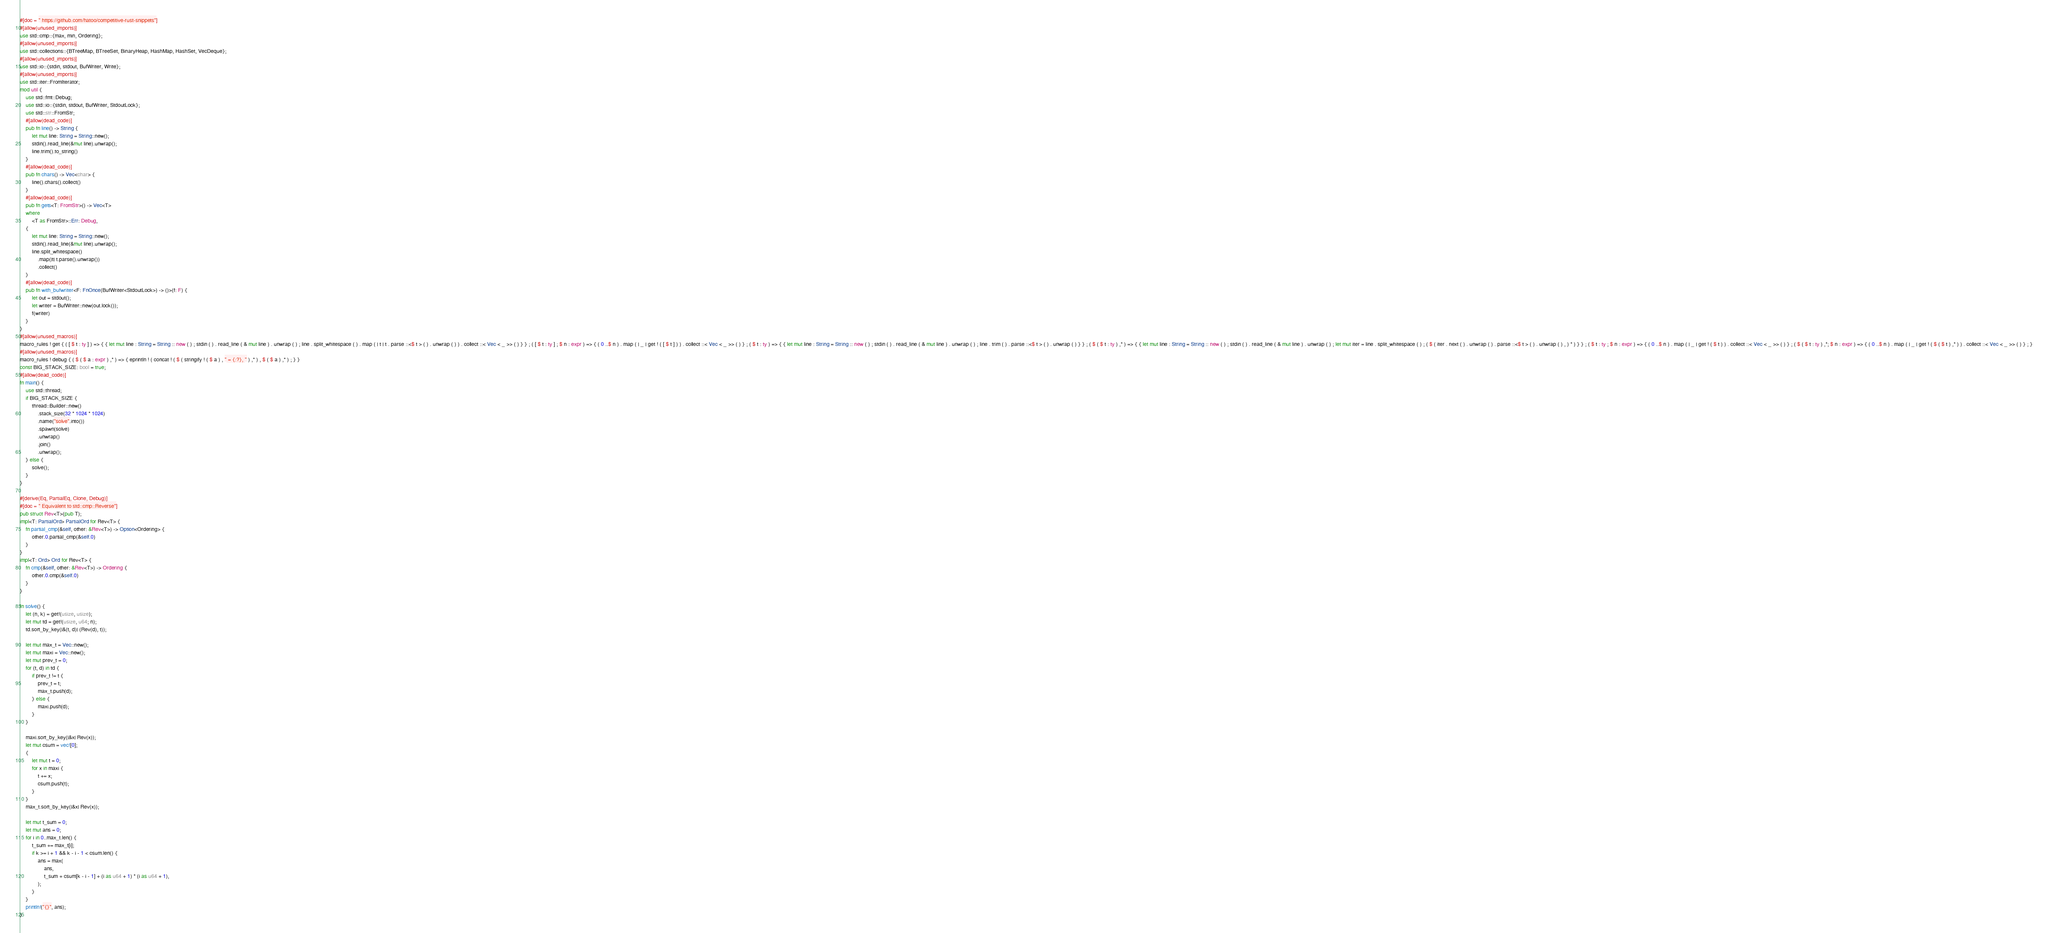<code> <loc_0><loc_0><loc_500><loc_500><_Rust_>#[doc = " https://github.com/hatoo/competitive-rust-snippets"]
#[allow(unused_imports)]
use std::cmp::{max, min, Ordering};
#[allow(unused_imports)]
use std::collections::{BTreeMap, BTreeSet, BinaryHeap, HashMap, HashSet, VecDeque};
#[allow(unused_imports)]
use std::io::{stdin, stdout, BufWriter, Write};
#[allow(unused_imports)]
use std::iter::FromIterator;
mod util {
    use std::fmt::Debug;
    use std::io::{stdin, stdout, BufWriter, StdoutLock};
    use std::str::FromStr;
    #[allow(dead_code)]
    pub fn line() -> String {
        let mut line: String = String::new();
        stdin().read_line(&mut line).unwrap();
        line.trim().to_string()
    }
    #[allow(dead_code)]
    pub fn chars() -> Vec<char> {
        line().chars().collect()
    }
    #[allow(dead_code)]
    pub fn gets<T: FromStr>() -> Vec<T>
    where
        <T as FromStr>::Err: Debug,
    {
        let mut line: String = String::new();
        stdin().read_line(&mut line).unwrap();
        line.split_whitespace()
            .map(|t| t.parse().unwrap())
            .collect()
    }
    #[allow(dead_code)]
    pub fn with_bufwriter<F: FnOnce(BufWriter<StdoutLock>) -> ()>(f: F) {
        let out = stdout();
        let writer = BufWriter::new(out.lock());
        f(writer)
    }
}
#[allow(unused_macros)]
macro_rules ! get { ( [ $ t : ty ] ) => { { let mut line : String = String :: new ( ) ; stdin ( ) . read_line ( & mut line ) . unwrap ( ) ; line . split_whitespace ( ) . map ( | t | t . parse ::<$ t > ( ) . unwrap ( ) ) . collect ::< Vec < _ >> ( ) } } ; ( [ $ t : ty ] ; $ n : expr ) => { ( 0 ..$ n ) . map ( | _ | get ! ( [ $ t ] ) ) . collect ::< Vec < _ >> ( ) } ; ( $ t : ty ) => { { let mut line : String = String :: new ( ) ; stdin ( ) . read_line ( & mut line ) . unwrap ( ) ; line . trim ( ) . parse ::<$ t > ( ) . unwrap ( ) } } ; ( $ ( $ t : ty ) ,* ) => { { let mut line : String = String :: new ( ) ; stdin ( ) . read_line ( & mut line ) . unwrap ( ) ; let mut iter = line . split_whitespace ( ) ; ( $ ( iter . next ( ) . unwrap ( ) . parse ::<$ t > ( ) . unwrap ( ) , ) * ) } } ; ( $ t : ty ; $ n : expr ) => { ( 0 ..$ n ) . map ( | _ | get ! ( $ t ) ) . collect ::< Vec < _ >> ( ) } ; ( $ ( $ t : ty ) ,*; $ n : expr ) => { ( 0 ..$ n ) . map ( | _ | get ! ( $ ( $ t ) ,* ) ) . collect ::< Vec < _ >> ( ) } ; }
#[allow(unused_macros)]
macro_rules ! debug { ( $ ( $ a : expr ) ,* ) => { eprintln ! ( concat ! ( $ ( stringify ! ( $ a ) , " = {:?}, " ) ,* ) , $ ( $ a ) ,* ) ; } }
const BIG_STACK_SIZE: bool = true;
#[allow(dead_code)]
fn main() {
    use std::thread;
    if BIG_STACK_SIZE {
        thread::Builder::new()
            .stack_size(32 * 1024 * 1024)
            .name("solve".into())
            .spawn(solve)
            .unwrap()
            .join()
            .unwrap();
    } else {
        solve();
    }
}

#[derive(Eq, PartialEq, Clone, Debug)]
#[doc = " Equivalent to std::cmp::Reverse"]
pub struct Rev<T>(pub T);
impl<T: PartialOrd> PartialOrd for Rev<T> {
    fn partial_cmp(&self, other: &Rev<T>) -> Option<Ordering> {
        other.0.partial_cmp(&self.0)
    }
}
impl<T: Ord> Ord for Rev<T> {
    fn cmp(&self, other: &Rev<T>) -> Ordering {
        other.0.cmp(&self.0)
    }
}

fn solve() {
    let (n, k) = get!(usize, usize);
    let mut td = get!(usize, u64; n);
    td.sort_by_key(|&(t, d)| (Rev(d), t));

    let mut max_t = Vec::new();
    let mut maxi = Vec::new();
    let mut prev_t = 0;
    for (t, d) in td {
        if prev_t != t {
            prev_t = t;
            max_t.push(d);
        } else {
            maxi.push(d);
        }
    }

    maxi.sort_by_key(|&x| Rev(x));
    let mut csum = vec![0];
    {
        let mut t = 0;
        for x in maxi {
            t += x;
            csum.push(t);
        }
    }
    max_t.sort_by_key(|&x| Rev(x));

    let mut t_sum = 0;
    let mut ans = 0;
    for i in 0..max_t.len() {
        t_sum += max_t[i];
        if k >= i + 1 && k - i - 1 < csum.len() {
            ans = max(
                ans,
                t_sum + csum[k - i - 1] + (i as u64 + 1) * (i as u64 + 1),
            );
        }
    }
    println!("{}", ans);
}
</code> 